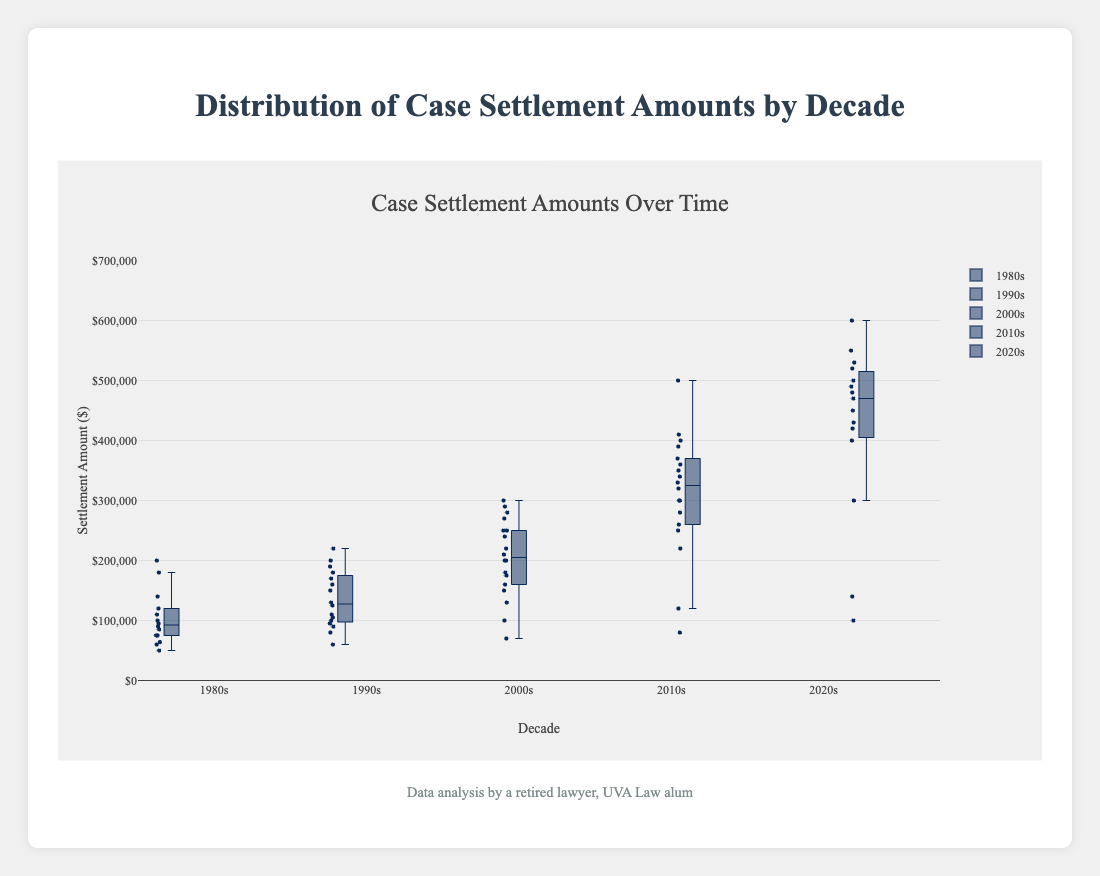What is the title of the figure? The title is displayed clearly at the top of the figure, indicating the subject matter of the plot, which is "Distribution of Case Settlement Amounts by Decade."
Answer: Distribution of Case Settlement Amounts by Decade What does the y-axis represent? The y-axis title "Settlement Amount ($)" indicates that it represents the settlement amounts in dollars for the cases across the decades.
Answer: Settlement Amount ($) Which decade has the highest median settlement amount? To find the decade with the highest median settlement amount, locate the median line within each box plot. The 2020s have the highest median, as their median line is the highest among all the boxes.
Answer: 2020s Which decade shows the greatest spread in settlement amounts? The spread or range of settlement amounts is indicated by the distance between the minimum and maximum values (whiskers) of the box plots. The 2020s show the greatest spread, with the range spanning from approximately $100,000 to $600,000.
Answer: 2020s Compare the interquartile ranges (IQR) of the 2010s and 2020s. Which is larger? The IQR is the distance between the first quartile (Q1) and the third quartile (Q3) in each box plot. The 2020s have a larger IQR than the 2010s because their box (representing Q1 to Q3) is larger than that of the 2010s.
Answer: 2020s Which decade has the smallest minimum settlement amount? The minimum settlement amount is represented by the bottom whisker of each box plot. The 1980s have the smallest minimum, approximately $50,000.
Answer: 1980s Are there any apparent outliers in the data? If so, in which decade(s)? Outliers are represented by individual points outside the whiskers of the box plots. In the 1980s, the point around $200,000 is an outlier. Similarly, other potential outliers are found in the 1990s and 2000s, but the 1980s have the most distinct ones.
Answer: 1980s, 1990s, 2000s How do median settlement amounts change over the decades? The median lines in the box plots indicate that the settlement amounts increase over the decades, from the 1980s to 2020s. Each subsequent decade generally has a higher median settlement amount than the previous one.
Answer: Increasing Which decade has the smallest interquartile range (IQR)? The smallest IQR can be identified by the smallest distance between Q1 and Q3 in the box plots. The 1980s appear to have the smallest IQR, indicating less variability within the central 50% of data.
Answer: 1980s 